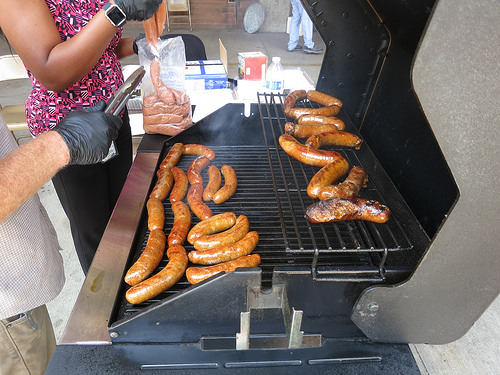<image>
Is there a meat under the tongs? Yes. The meat is positioned underneath the tongs, with the tongs above it in the vertical space. 